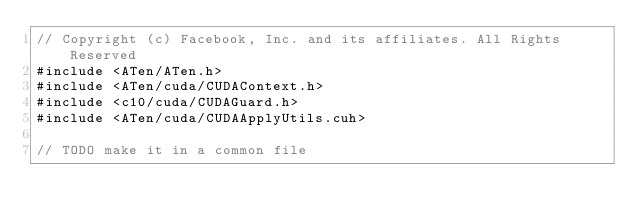<code> <loc_0><loc_0><loc_500><loc_500><_Cuda_>// Copyright (c) Facebook, Inc. and its affiliates. All Rights Reserved
#include <ATen/ATen.h>
#include <ATen/cuda/CUDAContext.h>
#include <c10/cuda/CUDAGuard.h>
#include <ATen/cuda/CUDAApplyUtils.cuh>

// TODO make it in a common file</code> 